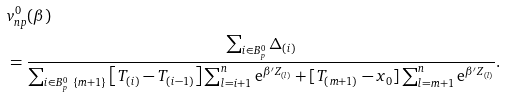<formula> <loc_0><loc_0><loc_500><loc_500>& v _ { n p } ^ { 0 } ( \beta ) \\ & = \frac { \sum _ { i \in B _ { p } ^ { 0 } } \Delta _ { ( i ) } } { \sum _ { i \in B _ { p } ^ { 0 } \ \{ m + 1 \} } \left [ T _ { ( i ) } - T _ { ( i - 1 ) } \right ] \sum _ { l = i + 1 } ^ { n } \text {e} ^ { \beta ^ { \prime } Z _ { ( l ) } } + [ T _ { ( m + 1 ) } - x _ { 0 } ] \sum _ { l = m + 1 } ^ { n } \text {e} ^ { \beta ^ { \prime } Z _ { ( l ) } } } .</formula> 